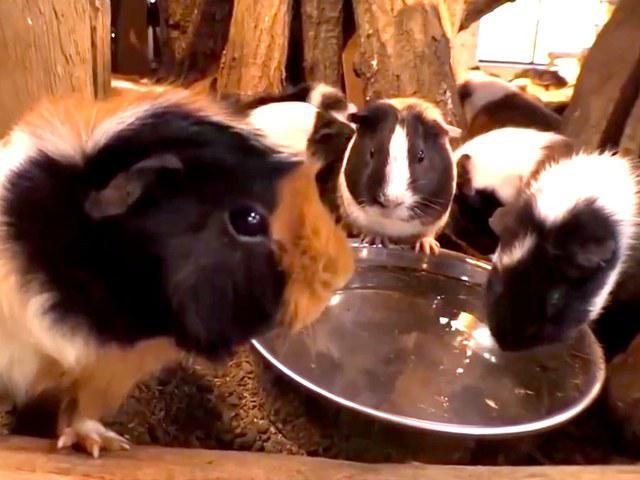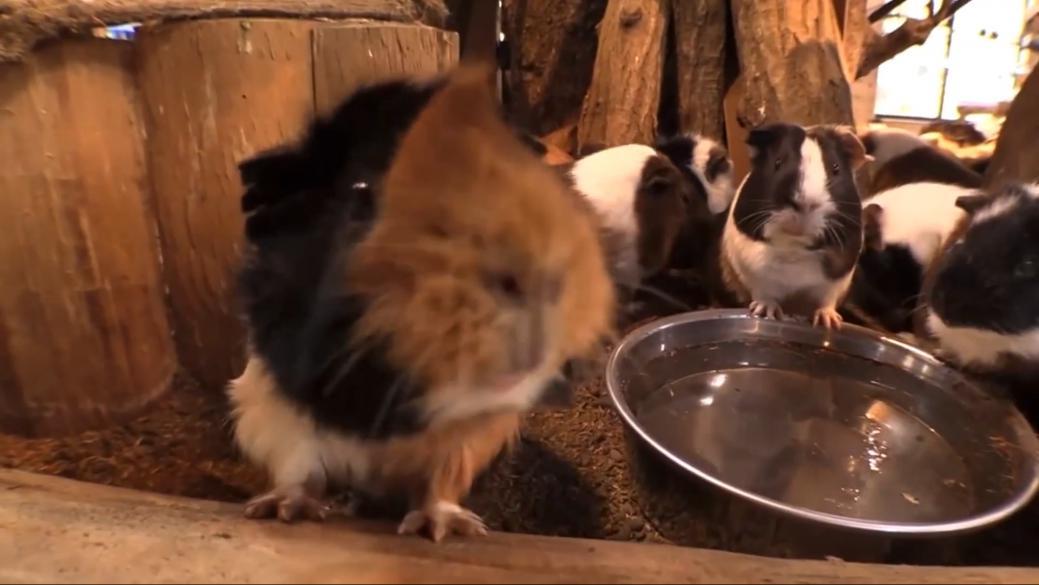The first image is the image on the left, the second image is the image on the right. For the images displayed, is the sentence "There is a bowl in the image on the right." factually correct? Answer yes or no. Yes. 